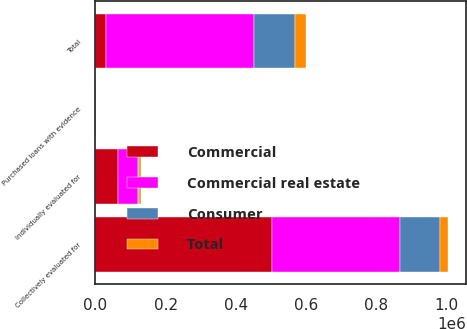Convert chart to OTSL. <chart><loc_0><loc_0><loc_500><loc_500><stacked_bar_chart><ecel><fcel>Individually evaluated for<fcel>Collectively evaluated for<fcel>Purchased loans with evidence<fcel>Total<nl><fcel>Commercial real estate<fcel>55951<fcel>364703<fcel>66<fcel>420720<nl><fcel>Consumer<fcel>2620<fcel>113202<fcel>105<fcel>115927<nl><fcel>Total<fcel>5995<fcel>24483<fcel>397<fcel>30875<nl><fcel>Commercial<fcel>64566<fcel>502388<fcel>568<fcel>30875<nl></chart> 